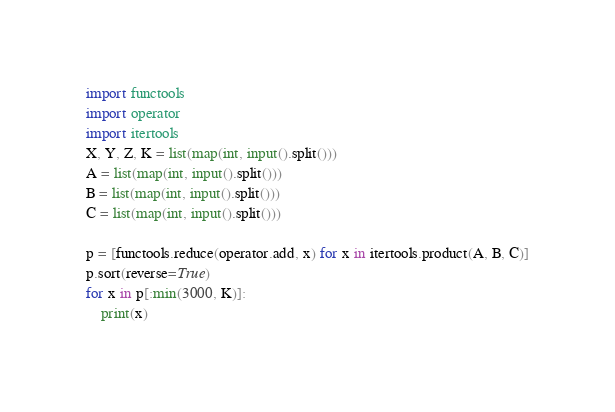Convert code to text. <code><loc_0><loc_0><loc_500><loc_500><_Python_>import functools
import operator
import itertools
X, Y, Z, K = list(map(int, input().split()))
A = list(map(int, input().split()))
B = list(map(int, input().split()))
C = list(map(int, input().split()))

p = [functools.reduce(operator.add, x) for x in itertools.product(A, B, C)]
p.sort(reverse=True)
for x in p[:min(3000, K)]:
    print(x)</code> 